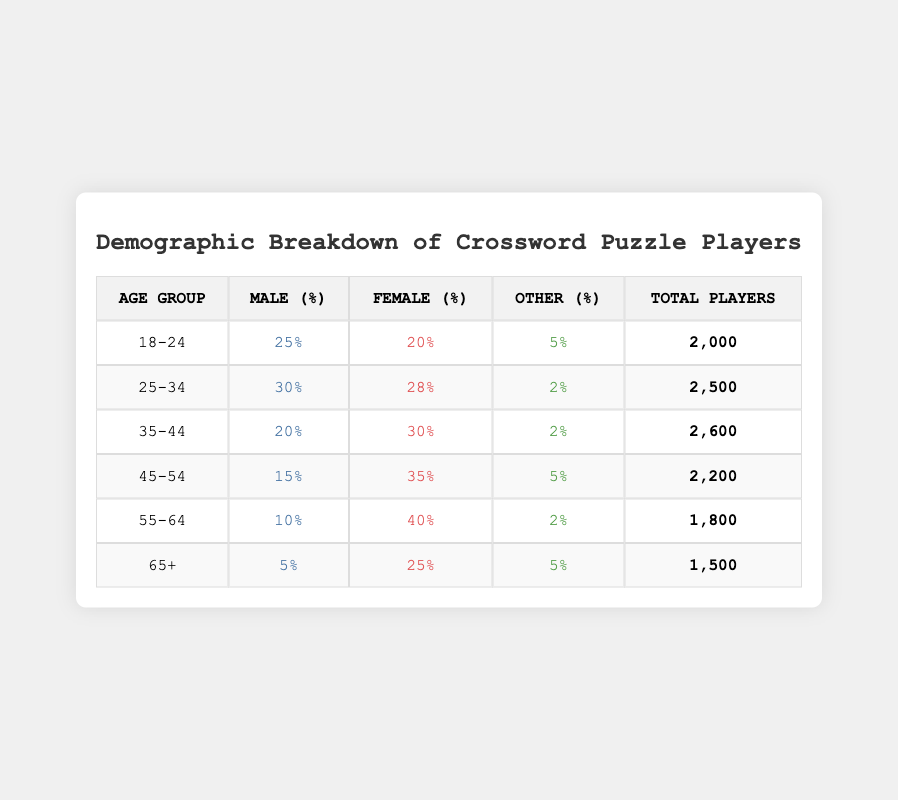What is the total number of players in the age group 25-34? The table shows that the total number of players in the age group 25-34 is listed directly as 2,500.
Answer: 2,500 What percentage of male players are in the age group 45-54? The table indicates that the male percentage in the 45-54 age group is 15%.
Answer: 15% Is the female percentage higher in the age group 35-44 than in the age group 55-64? By comparing the two age groups, the female percentage in 35-44 is 30%, while in 55-64 it is 40%. Thus, yes, 40% is higher than 30%.
Answer: Yes What is the total percentage of players who identify as 'Other' across all age groups? Adding the 'Other' percentages across all groups: 5 + 2 + 2 + 5 + 2 + 5 = 21%. Thus, the total percentage of players identifying as 'Other' is 21%.
Answer: 21% Which age group has the highest percentage of female players? The table shows that the highest female percentage is in the 55-64 age group at 40%.
Answer: 55-64 What is the average percentage of male players across all age groups? To find the average, sum the male percentages: 25 + 30 + 20 + 15 + 10 + 5 = 105 and divide by 6 (the number of age groups). The average is 105 / 6 = 17.5%.
Answer: 17.5% Is it true that the combined total of players aged 18-24 and 25-34 is more than 4,000? The total number of players aged 18-24 is 2,000, and for 25-34 is 2,500. The combined total is 2,000 + 2,500 = 4,500, which is indeed more than 4,000.
Answer: Yes What is the difference in total player numbers between the age groups 55-64 and 65+? The total number of players in the 55-64 age group is 1,800, while for 65+ it is 1,500. The difference is 1,800 - 1,500 = 300.
Answer: 300 Which age group has the lowest percentage of male players? From the table, the lowest male percentage is in the 65+ age group at 5%.
Answer: 65+ 